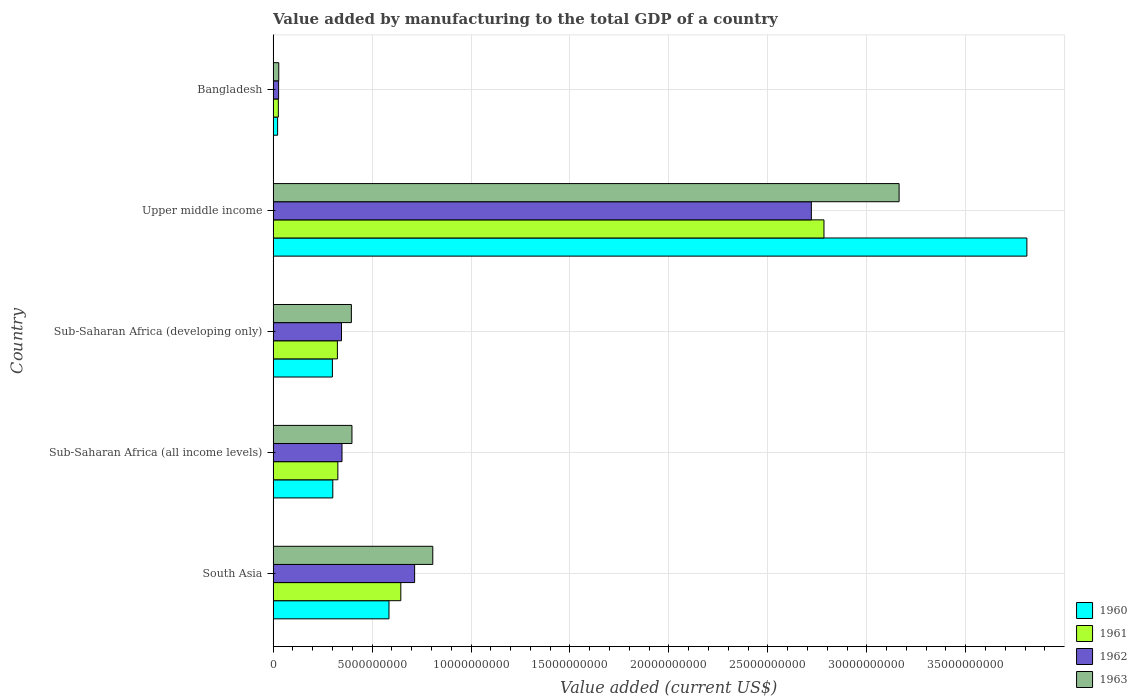Are the number of bars per tick equal to the number of legend labels?
Provide a short and direct response. Yes. How many bars are there on the 1st tick from the bottom?
Offer a terse response. 4. What is the label of the 3rd group of bars from the top?
Give a very brief answer. Sub-Saharan Africa (developing only). What is the value added by manufacturing to the total GDP in 1963 in Bangladesh?
Keep it short and to the point. 2.85e+08. Across all countries, what is the maximum value added by manufacturing to the total GDP in 1962?
Offer a terse response. 2.72e+1. Across all countries, what is the minimum value added by manufacturing to the total GDP in 1962?
Offer a terse response. 2.77e+08. In which country was the value added by manufacturing to the total GDP in 1961 maximum?
Offer a very short reply. Upper middle income. What is the total value added by manufacturing to the total GDP in 1963 in the graph?
Your answer should be compact. 4.79e+1. What is the difference between the value added by manufacturing to the total GDP in 1961 in Bangladesh and that in Sub-Saharan Africa (all income levels)?
Your answer should be compact. -3.01e+09. What is the difference between the value added by manufacturing to the total GDP in 1961 in South Asia and the value added by manufacturing to the total GDP in 1963 in Bangladesh?
Your answer should be very brief. 6.17e+09. What is the average value added by manufacturing to the total GDP in 1961 per country?
Keep it short and to the point. 8.21e+09. What is the difference between the value added by manufacturing to the total GDP in 1960 and value added by manufacturing to the total GDP in 1962 in Upper middle income?
Keep it short and to the point. 1.09e+1. In how many countries, is the value added by manufacturing to the total GDP in 1963 greater than 9000000000 US$?
Offer a very short reply. 1. What is the ratio of the value added by manufacturing to the total GDP in 1962 in Bangladesh to that in Upper middle income?
Offer a terse response. 0.01. Is the value added by manufacturing to the total GDP in 1960 in Bangladesh less than that in Sub-Saharan Africa (all income levels)?
Make the answer very short. Yes. Is the difference between the value added by manufacturing to the total GDP in 1960 in Sub-Saharan Africa (all income levels) and Sub-Saharan Africa (developing only) greater than the difference between the value added by manufacturing to the total GDP in 1962 in Sub-Saharan Africa (all income levels) and Sub-Saharan Africa (developing only)?
Your answer should be very brief. No. What is the difference between the highest and the second highest value added by manufacturing to the total GDP in 1962?
Ensure brevity in your answer.  2.00e+1. What is the difference between the highest and the lowest value added by manufacturing to the total GDP in 1962?
Offer a very short reply. 2.69e+1. In how many countries, is the value added by manufacturing to the total GDP in 1960 greater than the average value added by manufacturing to the total GDP in 1960 taken over all countries?
Your response must be concise. 1. What does the 2nd bar from the bottom in Sub-Saharan Africa (developing only) represents?
Keep it short and to the point. 1961. Is it the case that in every country, the sum of the value added by manufacturing to the total GDP in 1961 and value added by manufacturing to the total GDP in 1960 is greater than the value added by manufacturing to the total GDP in 1962?
Offer a very short reply. Yes. Are all the bars in the graph horizontal?
Offer a terse response. Yes. How many countries are there in the graph?
Your response must be concise. 5. What is the difference between two consecutive major ticks on the X-axis?
Your response must be concise. 5.00e+09. Are the values on the major ticks of X-axis written in scientific E-notation?
Keep it short and to the point. No. Does the graph contain any zero values?
Keep it short and to the point. No. Does the graph contain grids?
Provide a short and direct response. Yes. Where does the legend appear in the graph?
Ensure brevity in your answer.  Bottom right. How are the legend labels stacked?
Keep it short and to the point. Vertical. What is the title of the graph?
Your answer should be compact. Value added by manufacturing to the total GDP of a country. Does "1980" appear as one of the legend labels in the graph?
Give a very brief answer. No. What is the label or title of the X-axis?
Offer a terse response. Value added (current US$). What is the Value added (current US$) in 1960 in South Asia?
Ensure brevity in your answer.  5.86e+09. What is the Value added (current US$) of 1961 in South Asia?
Your response must be concise. 6.45e+09. What is the Value added (current US$) of 1962 in South Asia?
Offer a terse response. 7.15e+09. What is the Value added (current US$) in 1963 in South Asia?
Provide a short and direct response. 8.07e+09. What is the Value added (current US$) in 1960 in Sub-Saharan Africa (all income levels)?
Your answer should be compact. 3.02e+09. What is the Value added (current US$) of 1961 in Sub-Saharan Africa (all income levels)?
Your answer should be very brief. 3.27e+09. What is the Value added (current US$) of 1962 in Sub-Saharan Africa (all income levels)?
Ensure brevity in your answer.  3.48e+09. What is the Value added (current US$) of 1963 in Sub-Saharan Africa (all income levels)?
Your answer should be compact. 3.98e+09. What is the Value added (current US$) in 1960 in Sub-Saharan Africa (developing only)?
Offer a very short reply. 2.99e+09. What is the Value added (current US$) of 1961 in Sub-Saharan Africa (developing only)?
Offer a terse response. 3.25e+09. What is the Value added (current US$) in 1962 in Sub-Saharan Africa (developing only)?
Ensure brevity in your answer.  3.46e+09. What is the Value added (current US$) in 1963 in Sub-Saharan Africa (developing only)?
Make the answer very short. 3.95e+09. What is the Value added (current US$) of 1960 in Upper middle income?
Offer a terse response. 3.81e+1. What is the Value added (current US$) of 1961 in Upper middle income?
Your answer should be very brief. 2.78e+1. What is the Value added (current US$) in 1962 in Upper middle income?
Provide a short and direct response. 2.72e+1. What is the Value added (current US$) of 1963 in Upper middle income?
Keep it short and to the point. 3.16e+1. What is the Value added (current US$) in 1960 in Bangladesh?
Offer a very short reply. 2.27e+08. What is the Value added (current US$) of 1961 in Bangladesh?
Your answer should be compact. 2.64e+08. What is the Value added (current US$) of 1962 in Bangladesh?
Offer a very short reply. 2.77e+08. What is the Value added (current US$) of 1963 in Bangladesh?
Offer a very short reply. 2.85e+08. Across all countries, what is the maximum Value added (current US$) in 1960?
Your response must be concise. 3.81e+1. Across all countries, what is the maximum Value added (current US$) in 1961?
Your response must be concise. 2.78e+1. Across all countries, what is the maximum Value added (current US$) of 1962?
Your answer should be compact. 2.72e+1. Across all countries, what is the maximum Value added (current US$) of 1963?
Your answer should be very brief. 3.16e+1. Across all countries, what is the minimum Value added (current US$) in 1960?
Ensure brevity in your answer.  2.27e+08. Across all countries, what is the minimum Value added (current US$) of 1961?
Offer a terse response. 2.64e+08. Across all countries, what is the minimum Value added (current US$) in 1962?
Provide a short and direct response. 2.77e+08. Across all countries, what is the minimum Value added (current US$) in 1963?
Provide a short and direct response. 2.85e+08. What is the total Value added (current US$) in 1960 in the graph?
Offer a terse response. 5.02e+1. What is the total Value added (current US$) in 1961 in the graph?
Ensure brevity in your answer.  4.11e+1. What is the total Value added (current US$) in 1962 in the graph?
Provide a short and direct response. 4.16e+1. What is the total Value added (current US$) in 1963 in the graph?
Your answer should be compact. 4.79e+1. What is the difference between the Value added (current US$) in 1960 in South Asia and that in Sub-Saharan Africa (all income levels)?
Provide a short and direct response. 2.84e+09. What is the difference between the Value added (current US$) of 1961 in South Asia and that in Sub-Saharan Africa (all income levels)?
Keep it short and to the point. 3.18e+09. What is the difference between the Value added (current US$) of 1962 in South Asia and that in Sub-Saharan Africa (all income levels)?
Offer a very short reply. 3.67e+09. What is the difference between the Value added (current US$) in 1963 in South Asia and that in Sub-Saharan Africa (all income levels)?
Provide a short and direct response. 4.08e+09. What is the difference between the Value added (current US$) in 1960 in South Asia and that in Sub-Saharan Africa (developing only)?
Ensure brevity in your answer.  2.86e+09. What is the difference between the Value added (current US$) in 1961 in South Asia and that in Sub-Saharan Africa (developing only)?
Keep it short and to the point. 3.21e+09. What is the difference between the Value added (current US$) of 1962 in South Asia and that in Sub-Saharan Africa (developing only)?
Provide a short and direct response. 3.70e+09. What is the difference between the Value added (current US$) in 1963 in South Asia and that in Sub-Saharan Africa (developing only)?
Provide a succinct answer. 4.11e+09. What is the difference between the Value added (current US$) in 1960 in South Asia and that in Upper middle income?
Your answer should be compact. -3.22e+1. What is the difference between the Value added (current US$) in 1961 in South Asia and that in Upper middle income?
Your response must be concise. -2.14e+1. What is the difference between the Value added (current US$) of 1962 in South Asia and that in Upper middle income?
Provide a short and direct response. -2.00e+1. What is the difference between the Value added (current US$) of 1963 in South Asia and that in Upper middle income?
Offer a terse response. -2.36e+1. What is the difference between the Value added (current US$) in 1960 in South Asia and that in Bangladesh?
Ensure brevity in your answer.  5.63e+09. What is the difference between the Value added (current US$) of 1961 in South Asia and that in Bangladesh?
Your answer should be very brief. 6.19e+09. What is the difference between the Value added (current US$) of 1962 in South Asia and that in Bangladesh?
Provide a short and direct response. 6.87e+09. What is the difference between the Value added (current US$) in 1963 in South Asia and that in Bangladesh?
Your answer should be compact. 7.78e+09. What is the difference between the Value added (current US$) in 1960 in Sub-Saharan Africa (all income levels) and that in Sub-Saharan Africa (developing only)?
Offer a very short reply. 2.16e+07. What is the difference between the Value added (current US$) in 1961 in Sub-Saharan Africa (all income levels) and that in Sub-Saharan Africa (developing only)?
Provide a succinct answer. 2.34e+07. What is the difference between the Value added (current US$) in 1962 in Sub-Saharan Africa (all income levels) and that in Sub-Saharan Africa (developing only)?
Make the answer very short. 2.49e+07. What is the difference between the Value added (current US$) in 1963 in Sub-Saharan Africa (all income levels) and that in Sub-Saharan Africa (developing only)?
Keep it short and to the point. 2.85e+07. What is the difference between the Value added (current US$) of 1960 in Sub-Saharan Africa (all income levels) and that in Upper middle income?
Provide a succinct answer. -3.51e+1. What is the difference between the Value added (current US$) in 1961 in Sub-Saharan Africa (all income levels) and that in Upper middle income?
Keep it short and to the point. -2.46e+1. What is the difference between the Value added (current US$) in 1962 in Sub-Saharan Africa (all income levels) and that in Upper middle income?
Your response must be concise. -2.37e+1. What is the difference between the Value added (current US$) of 1963 in Sub-Saharan Africa (all income levels) and that in Upper middle income?
Your response must be concise. -2.76e+1. What is the difference between the Value added (current US$) of 1960 in Sub-Saharan Africa (all income levels) and that in Bangladesh?
Give a very brief answer. 2.79e+09. What is the difference between the Value added (current US$) of 1961 in Sub-Saharan Africa (all income levels) and that in Bangladesh?
Give a very brief answer. 3.01e+09. What is the difference between the Value added (current US$) in 1962 in Sub-Saharan Africa (all income levels) and that in Bangladesh?
Offer a terse response. 3.20e+09. What is the difference between the Value added (current US$) of 1963 in Sub-Saharan Africa (all income levels) and that in Bangladesh?
Keep it short and to the point. 3.70e+09. What is the difference between the Value added (current US$) in 1960 in Sub-Saharan Africa (developing only) and that in Upper middle income?
Offer a very short reply. -3.51e+1. What is the difference between the Value added (current US$) in 1961 in Sub-Saharan Africa (developing only) and that in Upper middle income?
Your answer should be compact. -2.46e+1. What is the difference between the Value added (current US$) in 1962 in Sub-Saharan Africa (developing only) and that in Upper middle income?
Make the answer very short. -2.37e+1. What is the difference between the Value added (current US$) of 1963 in Sub-Saharan Africa (developing only) and that in Upper middle income?
Offer a terse response. -2.77e+1. What is the difference between the Value added (current US$) in 1960 in Sub-Saharan Africa (developing only) and that in Bangladesh?
Keep it short and to the point. 2.77e+09. What is the difference between the Value added (current US$) of 1961 in Sub-Saharan Africa (developing only) and that in Bangladesh?
Provide a succinct answer. 2.98e+09. What is the difference between the Value added (current US$) of 1962 in Sub-Saharan Africa (developing only) and that in Bangladesh?
Your response must be concise. 3.18e+09. What is the difference between the Value added (current US$) in 1963 in Sub-Saharan Africa (developing only) and that in Bangladesh?
Offer a very short reply. 3.67e+09. What is the difference between the Value added (current US$) of 1960 in Upper middle income and that in Bangladesh?
Your response must be concise. 3.79e+1. What is the difference between the Value added (current US$) of 1961 in Upper middle income and that in Bangladesh?
Make the answer very short. 2.76e+1. What is the difference between the Value added (current US$) in 1962 in Upper middle income and that in Bangladesh?
Provide a short and direct response. 2.69e+1. What is the difference between the Value added (current US$) of 1963 in Upper middle income and that in Bangladesh?
Make the answer very short. 3.13e+1. What is the difference between the Value added (current US$) in 1960 in South Asia and the Value added (current US$) in 1961 in Sub-Saharan Africa (all income levels)?
Offer a very short reply. 2.58e+09. What is the difference between the Value added (current US$) in 1960 in South Asia and the Value added (current US$) in 1962 in Sub-Saharan Africa (all income levels)?
Your answer should be compact. 2.37e+09. What is the difference between the Value added (current US$) of 1960 in South Asia and the Value added (current US$) of 1963 in Sub-Saharan Africa (all income levels)?
Provide a succinct answer. 1.87e+09. What is the difference between the Value added (current US$) of 1961 in South Asia and the Value added (current US$) of 1962 in Sub-Saharan Africa (all income levels)?
Your answer should be very brief. 2.97e+09. What is the difference between the Value added (current US$) of 1961 in South Asia and the Value added (current US$) of 1963 in Sub-Saharan Africa (all income levels)?
Offer a terse response. 2.47e+09. What is the difference between the Value added (current US$) of 1962 in South Asia and the Value added (current US$) of 1963 in Sub-Saharan Africa (all income levels)?
Ensure brevity in your answer.  3.17e+09. What is the difference between the Value added (current US$) in 1960 in South Asia and the Value added (current US$) in 1961 in Sub-Saharan Africa (developing only)?
Provide a short and direct response. 2.61e+09. What is the difference between the Value added (current US$) in 1960 in South Asia and the Value added (current US$) in 1962 in Sub-Saharan Africa (developing only)?
Your answer should be compact. 2.40e+09. What is the difference between the Value added (current US$) of 1960 in South Asia and the Value added (current US$) of 1963 in Sub-Saharan Africa (developing only)?
Your response must be concise. 1.90e+09. What is the difference between the Value added (current US$) in 1961 in South Asia and the Value added (current US$) in 1962 in Sub-Saharan Africa (developing only)?
Make the answer very short. 3.00e+09. What is the difference between the Value added (current US$) in 1961 in South Asia and the Value added (current US$) in 1963 in Sub-Saharan Africa (developing only)?
Make the answer very short. 2.50e+09. What is the difference between the Value added (current US$) in 1962 in South Asia and the Value added (current US$) in 1963 in Sub-Saharan Africa (developing only)?
Your answer should be compact. 3.20e+09. What is the difference between the Value added (current US$) of 1960 in South Asia and the Value added (current US$) of 1961 in Upper middle income?
Ensure brevity in your answer.  -2.20e+1. What is the difference between the Value added (current US$) of 1960 in South Asia and the Value added (current US$) of 1962 in Upper middle income?
Your answer should be compact. -2.13e+1. What is the difference between the Value added (current US$) in 1960 in South Asia and the Value added (current US$) in 1963 in Upper middle income?
Provide a short and direct response. -2.58e+1. What is the difference between the Value added (current US$) of 1961 in South Asia and the Value added (current US$) of 1962 in Upper middle income?
Offer a terse response. -2.07e+1. What is the difference between the Value added (current US$) of 1961 in South Asia and the Value added (current US$) of 1963 in Upper middle income?
Ensure brevity in your answer.  -2.52e+1. What is the difference between the Value added (current US$) of 1962 in South Asia and the Value added (current US$) of 1963 in Upper middle income?
Make the answer very short. -2.45e+1. What is the difference between the Value added (current US$) of 1960 in South Asia and the Value added (current US$) of 1961 in Bangladesh?
Keep it short and to the point. 5.59e+09. What is the difference between the Value added (current US$) in 1960 in South Asia and the Value added (current US$) in 1962 in Bangladesh?
Provide a succinct answer. 5.58e+09. What is the difference between the Value added (current US$) in 1960 in South Asia and the Value added (current US$) in 1963 in Bangladesh?
Your response must be concise. 5.57e+09. What is the difference between the Value added (current US$) of 1961 in South Asia and the Value added (current US$) of 1962 in Bangladesh?
Provide a short and direct response. 6.18e+09. What is the difference between the Value added (current US$) of 1961 in South Asia and the Value added (current US$) of 1963 in Bangladesh?
Provide a succinct answer. 6.17e+09. What is the difference between the Value added (current US$) in 1962 in South Asia and the Value added (current US$) in 1963 in Bangladesh?
Make the answer very short. 6.87e+09. What is the difference between the Value added (current US$) in 1960 in Sub-Saharan Africa (all income levels) and the Value added (current US$) in 1961 in Sub-Saharan Africa (developing only)?
Keep it short and to the point. -2.32e+08. What is the difference between the Value added (current US$) in 1960 in Sub-Saharan Africa (all income levels) and the Value added (current US$) in 1962 in Sub-Saharan Africa (developing only)?
Your answer should be compact. -4.40e+08. What is the difference between the Value added (current US$) in 1960 in Sub-Saharan Africa (all income levels) and the Value added (current US$) in 1963 in Sub-Saharan Africa (developing only)?
Give a very brief answer. -9.39e+08. What is the difference between the Value added (current US$) of 1961 in Sub-Saharan Africa (all income levels) and the Value added (current US$) of 1962 in Sub-Saharan Africa (developing only)?
Offer a very short reply. -1.85e+08. What is the difference between the Value added (current US$) of 1961 in Sub-Saharan Africa (all income levels) and the Value added (current US$) of 1963 in Sub-Saharan Africa (developing only)?
Ensure brevity in your answer.  -6.84e+08. What is the difference between the Value added (current US$) of 1962 in Sub-Saharan Africa (all income levels) and the Value added (current US$) of 1963 in Sub-Saharan Africa (developing only)?
Offer a very short reply. -4.74e+08. What is the difference between the Value added (current US$) of 1960 in Sub-Saharan Africa (all income levels) and the Value added (current US$) of 1961 in Upper middle income?
Offer a very short reply. -2.48e+1. What is the difference between the Value added (current US$) of 1960 in Sub-Saharan Africa (all income levels) and the Value added (current US$) of 1962 in Upper middle income?
Provide a short and direct response. -2.42e+1. What is the difference between the Value added (current US$) in 1960 in Sub-Saharan Africa (all income levels) and the Value added (current US$) in 1963 in Upper middle income?
Your response must be concise. -2.86e+1. What is the difference between the Value added (current US$) in 1961 in Sub-Saharan Africa (all income levels) and the Value added (current US$) in 1962 in Upper middle income?
Your response must be concise. -2.39e+1. What is the difference between the Value added (current US$) in 1961 in Sub-Saharan Africa (all income levels) and the Value added (current US$) in 1963 in Upper middle income?
Offer a very short reply. -2.84e+1. What is the difference between the Value added (current US$) in 1962 in Sub-Saharan Africa (all income levels) and the Value added (current US$) in 1963 in Upper middle income?
Your answer should be compact. -2.82e+1. What is the difference between the Value added (current US$) of 1960 in Sub-Saharan Africa (all income levels) and the Value added (current US$) of 1961 in Bangladesh?
Provide a short and direct response. 2.75e+09. What is the difference between the Value added (current US$) of 1960 in Sub-Saharan Africa (all income levels) and the Value added (current US$) of 1962 in Bangladesh?
Provide a short and direct response. 2.74e+09. What is the difference between the Value added (current US$) of 1960 in Sub-Saharan Africa (all income levels) and the Value added (current US$) of 1963 in Bangladesh?
Provide a succinct answer. 2.73e+09. What is the difference between the Value added (current US$) in 1961 in Sub-Saharan Africa (all income levels) and the Value added (current US$) in 1962 in Bangladesh?
Offer a very short reply. 2.99e+09. What is the difference between the Value added (current US$) in 1961 in Sub-Saharan Africa (all income levels) and the Value added (current US$) in 1963 in Bangladesh?
Make the answer very short. 2.99e+09. What is the difference between the Value added (current US$) of 1962 in Sub-Saharan Africa (all income levels) and the Value added (current US$) of 1963 in Bangladesh?
Your response must be concise. 3.20e+09. What is the difference between the Value added (current US$) of 1960 in Sub-Saharan Africa (developing only) and the Value added (current US$) of 1961 in Upper middle income?
Offer a very short reply. -2.48e+1. What is the difference between the Value added (current US$) in 1960 in Sub-Saharan Africa (developing only) and the Value added (current US$) in 1962 in Upper middle income?
Keep it short and to the point. -2.42e+1. What is the difference between the Value added (current US$) of 1960 in Sub-Saharan Africa (developing only) and the Value added (current US$) of 1963 in Upper middle income?
Your answer should be compact. -2.86e+1. What is the difference between the Value added (current US$) of 1961 in Sub-Saharan Africa (developing only) and the Value added (current US$) of 1962 in Upper middle income?
Keep it short and to the point. -2.40e+1. What is the difference between the Value added (current US$) in 1961 in Sub-Saharan Africa (developing only) and the Value added (current US$) in 1963 in Upper middle income?
Your response must be concise. -2.84e+1. What is the difference between the Value added (current US$) of 1962 in Sub-Saharan Africa (developing only) and the Value added (current US$) of 1963 in Upper middle income?
Give a very brief answer. -2.82e+1. What is the difference between the Value added (current US$) in 1960 in Sub-Saharan Africa (developing only) and the Value added (current US$) in 1961 in Bangladesh?
Ensure brevity in your answer.  2.73e+09. What is the difference between the Value added (current US$) in 1960 in Sub-Saharan Africa (developing only) and the Value added (current US$) in 1962 in Bangladesh?
Make the answer very short. 2.72e+09. What is the difference between the Value added (current US$) in 1960 in Sub-Saharan Africa (developing only) and the Value added (current US$) in 1963 in Bangladesh?
Keep it short and to the point. 2.71e+09. What is the difference between the Value added (current US$) of 1961 in Sub-Saharan Africa (developing only) and the Value added (current US$) of 1962 in Bangladesh?
Make the answer very short. 2.97e+09. What is the difference between the Value added (current US$) in 1961 in Sub-Saharan Africa (developing only) and the Value added (current US$) in 1963 in Bangladesh?
Provide a short and direct response. 2.96e+09. What is the difference between the Value added (current US$) of 1962 in Sub-Saharan Africa (developing only) and the Value added (current US$) of 1963 in Bangladesh?
Give a very brief answer. 3.17e+09. What is the difference between the Value added (current US$) of 1960 in Upper middle income and the Value added (current US$) of 1961 in Bangladesh?
Keep it short and to the point. 3.78e+1. What is the difference between the Value added (current US$) in 1960 in Upper middle income and the Value added (current US$) in 1962 in Bangladesh?
Provide a short and direct response. 3.78e+1. What is the difference between the Value added (current US$) of 1960 in Upper middle income and the Value added (current US$) of 1963 in Bangladesh?
Offer a terse response. 3.78e+1. What is the difference between the Value added (current US$) of 1961 in Upper middle income and the Value added (current US$) of 1962 in Bangladesh?
Offer a terse response. 2.76e+1. What is the difference between the Value added (current US$) in 1961 in Upper middle income and the Value added (current US$) in 1963 in Bangladesh?
Offer a very short reply. 2.76e+1. What is the difference between the Value added (current US$) of 1962 in Upper middle income and the Value added (current US$) of 1963 in Bangladesh?
Ensure brevity in your answer.  2.69e+1. What is the average Value added (current US$) in 1960 per country?
Your answer should be very brief. 1.00e+1. What is the average Value added (current US$) in 1961 per country?
Provide a succinct answer. 8.21e+09. What is the average Value added (current US$) of 1962 per country?
Your answer should be very brief. 8.31e+09. What is the average Value added (current US$) of 1963 per country?
Your answer should be very brief. 9.58e+09. What is the difference between the Value added (current US$) in 1960 and Value added (current US$) in 1961 in South Asia?
Ensure brevity in your answer.  -5.98e+08. What is the difference between the Value added (current US$) in 1960 and Value added (current US$) in 1962 in South Asia?
Your answer should be very brief. -1.30e+09. What is the difference between the Value added (current US$) in 1960 and Value added (current US$) in 1963 in South Asia?
Keep it short and to the point. -2.21e+09. What is the difference between the Value added (current US$) in 1961 and Value added (current US$) in 1962 in South Asia?
Give a very brief answer. -6.98e+08. What is the difference between the Value added (current US$) of 1961 and Value added (current US$) of 1963 in South Asia?
Your answer should be very brief. -1.61e+09. What is the difference between the Value added (current US$) in 1962 and Value added (current US$) in 1963 in South Asia?
Your answer should be compact. -9.17e+08. What is the difference between the Value added (current US$) of 1960 and Value added (current US$) of 1961 in Sub-Saharan Africa (all income levels)?
Provide a succinct answer. -2.55e+08. What is the difference between the Value added (current US$) of 1960 and Value added (current US$) of 1962 in Sub-Saharan Africa (all income levels)?
Offer a very short reply. -4.65e+08. What is the difference between the Value added (current US$) of 1960 and Value added (current US$) of 1963 in Sub-Saharan Africa (all income levels)?
Your response must be concise. -9.68e+08. What is the difference between the Value added (current US$) of 1961 and Value added (current US$) of 1962 in Sub-Saharan Africa (all income levels)?
Provide a short and direct response. -2.09e+08. What is the difference between the Value added (current US$) in 1961 and Value added (current US$) in 1963 in Sub-Saharan Africa (all income levels)?
Offer a terse response. -7.12e+08. What is the difference between the Value added (current US$) in 1962 and Value added (current US$) in 1963 in Sub-Saharan Africa (all income levels)?
Offer a terse response. -5.03e+08. What is the difference between the Value added (current US$) of 1960 and Value added (current US$) of 1961 in Sub-Saharan Africa (developing only)?
Keep it short and to the point. -2.54e+08. What is the difference between the Value added (current US$) in 1960 and Value added (current US$) in 1962 in Sub-Saharan Africa (developing only)?
Offer a terse response. -4.61e+08. What is the difference between the Value added (current US$) in 1960 and Value added (current US$) in 1963 in Sub-Saharan Africa (developing only)?
Your answer should be very brief. -9.61e+08. What is the difference between the Value added (current US$) in 1961 and Value added (current US$) in 1962 in Sub-Saharan Africa (developing only)?
Your response must be concise. -2.08e+08. What is the difference between the Value added (current US$) in 1961 and Value added (current US$) in 1963 in Sub-Saharan Africa (developing only)?
Provide a succinct answer. -7.07e+08. What is the difference between the Value added (current US$) of 1962 and Value added (current US$) of 1963 in Sub-Saharan Africa (developing only)?
Your answer should be very brief. -4.99e+08. What is the difference between the Value added (current US$) of 1960 and Value added (current US$) of 1961 in Upper middle income?
Make the answer very short. 1.03e+1. What is the difference between the Value added (current US$) in 1960 and Value added (current US$) in 1962 in Upper middle income?
Offer a very short reply. 1.09e+1. What is the difference between the Value added (current US$) of 1960 and Value added (current US$) of 1963 in Upper middle income?
Your response must be concise. 6.46e+09. What is the difference between the Value added (current US$) of 1961 and Value added (current US$) of 1962 in Upper middle income?
Offer a terse response. 6.38e+08. What is the difference between the Value added (current US$) in 1961 and Value added (current US$) in 1963 in Upper middle income?
Your answer should be compact. -3.80e+09. What is the difference between the Value added (current US$) of 1962 and Value added (current US$) of 1963 in Upper middle income?
Keep it short and to the point. -4.43e+09. What is the difference between the Value added (current US$) of 1960 and Value added (current US$) of 1961 in Bangladesh?
Offer a very short reply. -3.66e+07. What is the difference between the Value added (current US$) in 1960 and Value added (current US$) in 1962 in Bangladesh?
Your answer should be compact. -4.99e+07. What is the difference between the Value added (current US$) of 1960 and Value added (current US$) of 1963 in Bangladesh?
Offer a very short reply. -5.81e+07. What is the difference between the Value added (current US$) in 1961 and Value added (current US$) in 1962 in Bangladesh?
Your answer should be compact. -1.33e+07. What is the difference between the Value added (current US$) in 1961 and Value added (current US$) in 1963 in Bangladesh?
Make the answer very short. -2.15e+07. What is the difference between the Value added (current US$) in 1962 and Value added (current US$) in 1963 in Bangladesh?
Your answer should be very brief. -8.22e+06. What is the ratio of the Value added (current US$) in 1960 in South Asia to that in Sub-Saharan Africa (all income levels)?
Provide a succinct answer. 1.94. What is the ratio of the Value added (current US$) of 1961 in South Asia to that in Sub-Saharan Africa (all income levels)?
Your answer should be compact. 1.97. What is the ratio of the Value added (current US$) of 1962 in South Asia to that in Sub-Saharan Africa (all income levels)?
Offer a very short reply. 2.05. What is the ratio of the Value added (current US$) in 1963 in South Asia to that in Sub-Saharan Africa (all income levels)?
Your response must be concise. 2.03. What is the ratio of the Value added (current US$) of 1960 in South Asia to that in Sub-Saharan Africa (developing only)?
Your answer should be very brief. 1.96. What is the ratio of the Value added (current US$) of 1961 in South Asia to that in Sub-Saharan Africa (developing only)?
Your response must be concise. 1.99. What is the ratio of the Value added (current US$) of 1962 in South Asia to that in Sub-Saharan Africa (developing only)?
Ensure brevity in your answer.  2.07. What is the ratio of the Value added (current US$) in 1963 in South Asia to that in Sub-Saharan Africa (developing only)?
Offer a terse response. 2.04. What is the ratio of the Value added (current US$) in 1960 in South Asia to that in Upper middle income?
Give a very brief answer. 0.15. What is the ratio of the Value added (current US$) of 1961 in South Asia to that in Upper middle income?
Make the answer very short. 0.23. What is the ratio of the Value added (current US$) in 1962 in South Asia to that in Upper middle income?
Your answer should be compact. 0.26. What is the ratio of the Value added (current US$) of 1963 in South Asia to that in Upper middle income?
Ensure brevity in your answer.  0.26. What is the ratio of the Value added (current US$) in 1960 in South Asia to that in Bangladesh?
Provide a short and direct response. 25.79. What is the ratio of the Value added (current US$) in 1961 in South Asia to that in Bangladesh?
Provide a short and direct response. 24.48. What is the ratio of the Value added (current US$) in 1962 in South Asia to that in Bangladesh?
Offer a terse response. 25.83. What is the ratio of the Value added (current US$) of 1963 in South Asia to that in Bangladesh?
Ensure brevity in your answer.  28.3. What is the ratio of the Value added (current US$) of 1960 in Sub-Saharan Africa (all income levels) to that in Sub-Saharan Africa (developing only)?
Your answer should be very brief. 1.01. What is the ratio of the Value added (current US$) in 1960 in Sub-Saharan Africa (all income levels) to that in Upper middle income?
Offer a terse response. 0.08. What is the ratio of the Value added (current US$) in 1961 in Sub-Saharan Africa (all income levels) to that in Upper middle income?
Ensure brevity in your answer.  0.12. What is the ratio of the Value added (current US$) of 1962 in Sub-Saharan Africa (all income levels) to that in Upper middle income?
Keep it short and to the point. 0.13. What is the ratio of the Value added (current US$) of 1963 in Sub-Saharan Africa (all income levels) to that in Upper middle income?
Your answer should be compact. 0.13. What is the ratio of the Value added (current US$) in 1960 in Sub-Saharan Africa (all income levels) to that in Bangladesh?
Your answer should be compact. 13.29. What is the ratio of the Value added (current US$) in 1961 in Sub-Saharan Africa (all income levels) to that in Bangladesh?
Your response must be concise. 12.41. What is the ratio of the Value added (current US$) in 1962 in Sub-Saharan Africa (all income levels) to that in Bangladesh?
Provide a short and direct response. 12.57. What is the ratio of the Value added (current US$) of 1963 in Sub-Saharan Africa (all income levels) to that in Bangladesh?
Give a very brief answer. 13.97. What is the ratio of the Value added (current US$) of 1960 in Sub-Saharan Africa (developing only) to that in Upper middle income?
Offer a terse response. 0.08. What is the ratio of the Value added (current US$) of 1961 in Sub-Saharan Africa (developing only) to that in Upper middle income?
Your response must be concise. 0.12. What is the ratio of the Value added (current US$) in 1962 in Sub-Saharan Africa (developing only) to that in Upper middle income?
Keep it short and to the point. 0.13. What is the ratio of the Value added (current US$) in 1960 in Sub-Saharan Africa (developing only) to that in Bangladesh?
Provide a succinct answer. 13.19. What is the ratio of the Value added (current US$) of 1961 in Sub-Saharan Africa (developing only) to that in Bangladesh?
Ensure brevity in your answer.  12.32. What is the ratio of the Value added (current US$) of 1962 in Sub-Saharan Africa (developing only) to that in Bangladesh?
Make the answer very short. 12.48. What is the ratio of the Value added (current US$) in 1963 in Sub-Saharan Africa (developing only) to that in Bangladesh?
Keep it short and to the point. 13.87. What is the ratio of the Value added (current US$) of 1960 in Upper middle income to that in Bangladesh?
Offer a very short reply. 167.8. What is the ratio of the Value added (current US$) of 1961 in Upper middle income to that in Bangladesh?
Your response must be concise. 105.62. What is the ratio of the Value added (current US$) in 1962 in Upper middle income to that in Bangladesh?
Your answer should be very brief. 98.24. What is the ratio of the Value added (current US$) in 1963 in Upper middle income to that in Bangladesh?
Provide a short and direct response. 110.96. What is the difference between the highest and the second highest Value added (current US$) in 1960?
Your answer should be compact. 3.22e+1. What is the difference between the highest and the second highest Value added (current US$) in 1961?
Give a very brief answer. 2.14e+1. What is the difference between the highest and the second highest Value added (current US$) of 1962?
Offer a terse response. 2.00e+1. What is the difference between the highest and the second highest Value added (current US$) in 1963?
Ensure brevity in your answer.  2.36e+1. What is the difference between the highest and the lowest Value added (current US$) of 1960?
Offer a terse response. 3.79e+1. What is the difference between the highest and the lowest Value added (current US$) in 1961?
Your response must be concise. 2.76e+1. What is the difference between the highest and the lowest Value added (current US$) of 1962?
Your answer should be very brief. 2.69e+1. What is the difference between the highest and the lowest Value added (current US$) in 1963?
Keep it short and to the point. 3.13e+1. 